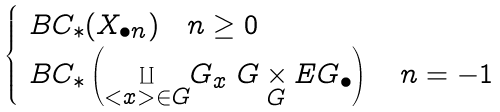Convert formula to latex. <formula><loc_0><loc_0><loc_500><loc_500>\begin{cases} { \ B } C _ { * } ( X _ { \bullet n } ) \quad n \geq 0 \\ { \ B } C _ { * } \left ( \underset { < x > \in G } { \coprod } G _ { x } \ G \underset { G } { \times } E G _ { \bullet } \right ) \quad n = - 1 \end{cases}</formula> 